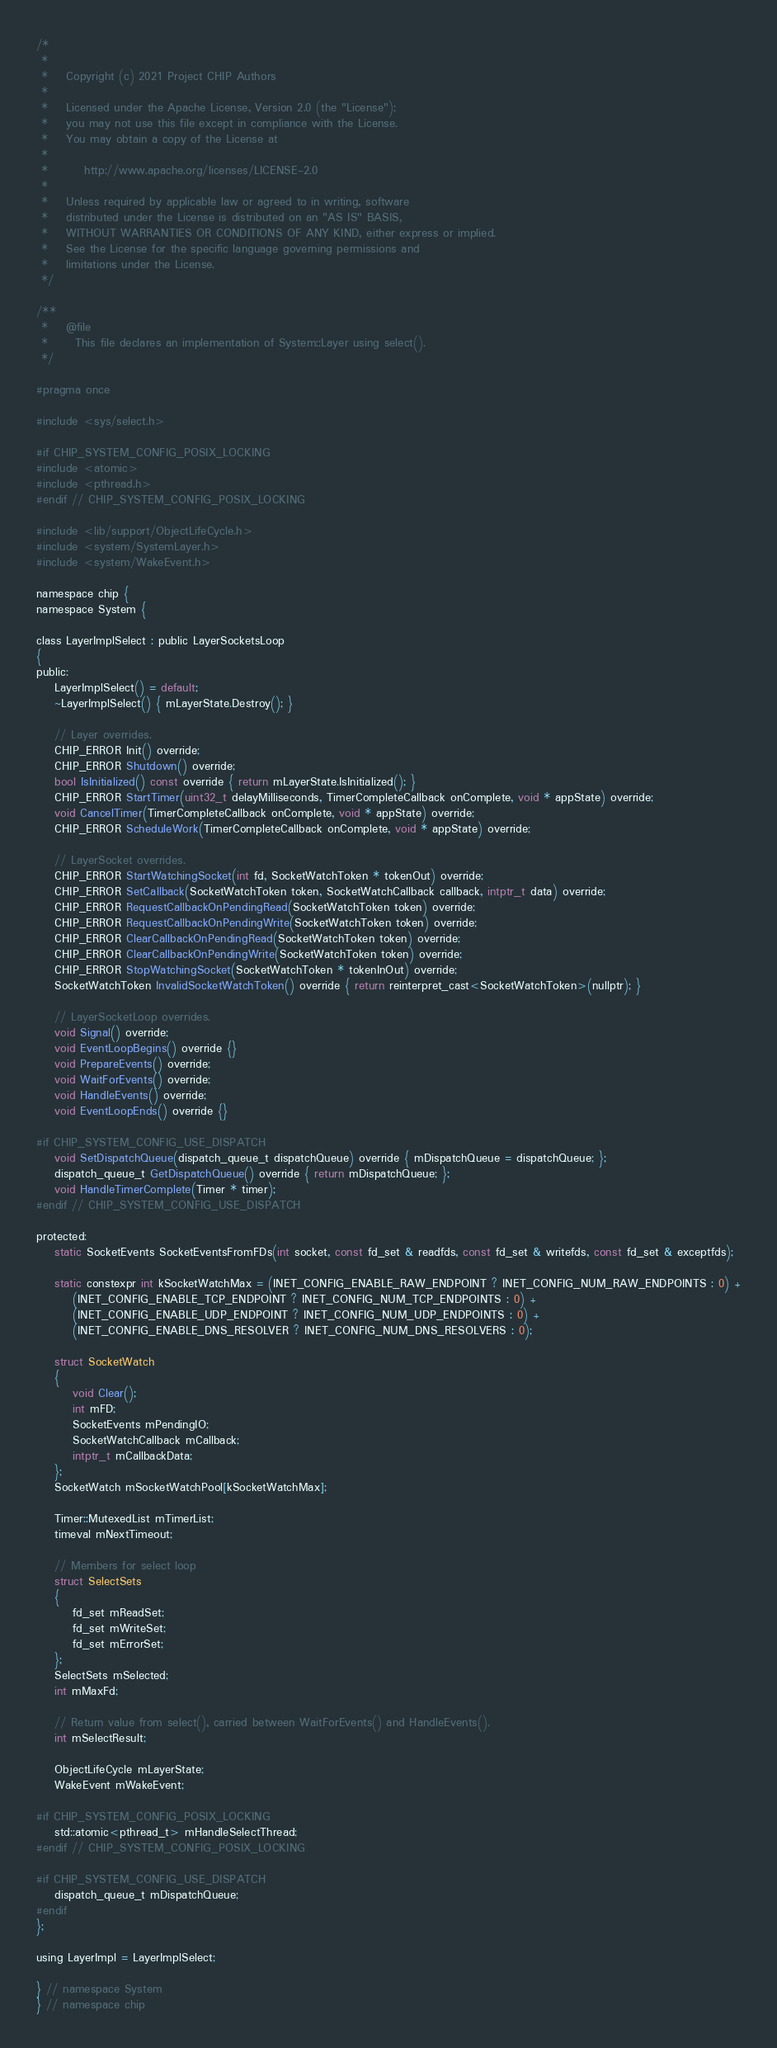Convert code to text. <code><loc_0><loc_0><loc_500><loc_500><_C_>/*
 *
 *    Copyright (c) 2021 Project CHIP Authors
 *
 *    Licensed under the Apache License, Version 2.0 (the "License");
 *    you may not use this file except in compliance with the License.
 *    You may obtain a copy of the License at
 *
 *        http://www.apache.org/licenses/LICENSE-2.0
 *
 *    Unless required by applicable law or agreed to in writing, software
 *    distributed under the License is distributed on an "AS IS" BASIS,
 *    WITHOUT WARRANTIES OR CONDITIONS OF ANY KIND, either express or implied.
 *    See the License for the specific language governing permissions and
 *    limitations under the License.
 */

/**
 *    @file
 *      This file declares an implementation of System::Layer using select().
 */

#pragma once

#include <sys/select.h>

#if CHIP_SYSTEM_CONFIG_POSIX_LOCKING
#include <atomic>
#include <pthread.h>
#endif // CHIP_SYSTEM_CONFIG_POSIX_LOCKING

#include <lib/support/ObjectLifeCycle.h>
#include <system/SystemLayer.h>
#include <system/WakeEvent.h>

namespace chip {
namespace System {

class LayerImplSelect : public LayerSocketsLoop
{
public:
    LayerImplSelect() = default;
    ~LayerImplSelect() { mLayerState.Destroy(); }

    // Layer overrides.
    CHIP_ERROR Init() override;
    CHIP_ERROR Shutdown() override;
    bool IsInitialized() const override { return mLayerState.IsInitialized(); }
    CHIP_ERROR StartTimer(uint32_t delayMilliseconds, TimerCompleteCallback onComplete, void * appState) override;
    void CancelTimer(TimerCompleteCallback onComplete, void * appState) override;
    CHIP_ERROR ScheduleWork(TimerCompleteCallback onComplete, void * appState) override;

    // LayerSocket overrides.
    CHIP_ERROR StartWatchingSocket(int fd, SocketWatchToken * tokenOut) override;
    CHIP_ERROR SetCallback(SocketWatchToken token, SocketWatchCallback callback, intptr_t data) override;
    CHIP_ERROR RequestCallbackOnPendingRead(SocketWatchToken token) override;
    CHIP_ERROR RequestCallbackOnPendingWrite(SocketWatchToken token) override;
    CHIP_ERROR ClearCallbackOnPendingRead(SocketWatchToken token) override;
    CHIP_ERROR ClearCallbackOnPendingWrite(SocketWatchToken token) override;
    CHIP_ERROR StopWatchingSocket(SocketWatchToken * tokenInOut) override;
    SocketWatchToken InvalidSocketWatchToken() override { return reinterpret_cast<SocketWatchToken>(nullptr); }

    // LayerSocketLoop overrides.
    void Signal() override;
    void EventLoopBegins() override {}
    void PrepareEvents() override;
    void WaitForEvents() override;
    void HandleEvents() override;
    void EventLoopEnds() override {}

#if CHIP_SYSTEM_CONFIG_USE_DISPATCH
    void SetDispatchQueue(dispatch_queue_t dispatchQueue) override { mDispatchQueue = dispatchQueue; };
    dispatch_queue_t GetDispatchQueue() override { return mDispatchQueue; };
    void HandleTimerComplete(Timer * timer);
#endif // CHIP_SYSTEM_CONFIG_USE_DISPATCH

protected:
    static SocketEvents SocketEventsFromFDs(int socket, const fd_set & readfds, const fd_set & writefds, const fd_set & exceptfds);

    static constexpr int kSocketWatchMax = (INET_CONFIG_ENABLE_RAW_ENDPOINT ? INET_CONFIG_NUM_RAW_ENDPOINTS : 0) +
        (INET_CONFIG_ENABLE_TCP_ENDPOINT ? INET_CONFIG_NUM_TCP_ENDPOINTS : 0) +
        (INET_CONFIG_ENABLE_UDP_ENDPOINT ? INET_CONFIG_NUM_UDP_ENDPOINTS : 0) +
        (INET_CONFIG_ENABLE_DNS_RESOLVER ? INET_CONFIG_NUM_DNS_RESOLVERS : 0);

    struct SocketWatch
    {
        void Clear();
        int mFD;
        SocketEvents mPendingIO;
        SocketWatchCallback mCallback;
        intptr_t mCallbackData;
    };
    SocketWatch mSocketWatchPool[kSocketWatchMax];

    Timer::MutexedList mTimerList;
    timeval mNextTimeout;

    // Members for select loop
    struct SelectSets
    {
        fd_set mReadSet;
        fd_set mWriteSet;
        fd_set mErrorSet;
    };
    SelectSets mSelected;
    int mMaxFd;

    // Return value from select(), carried between WaitForEvents() and HandleEvents().
    int mSelectResult;

    ObjectLifeCycle mLayerState;
    WakeEvent mWakeEvent;

#if CHIP_SYSTEM_CONFIG_POSIX_LOCKING
    std::atomic<pthread_t> mHandleSelectThread;
#endif // CHIP_SYSTEM_CONFIG_POSIX_LOCKING

#if CHIP_SYSTEM_CONFIG_USE_DISPATCH
    dispatch_queue_t mDispatchQueue;
#endif
};

using LayerImpl = LayerImplSelect;

} // namespace System
} // namespace chip
</code> 